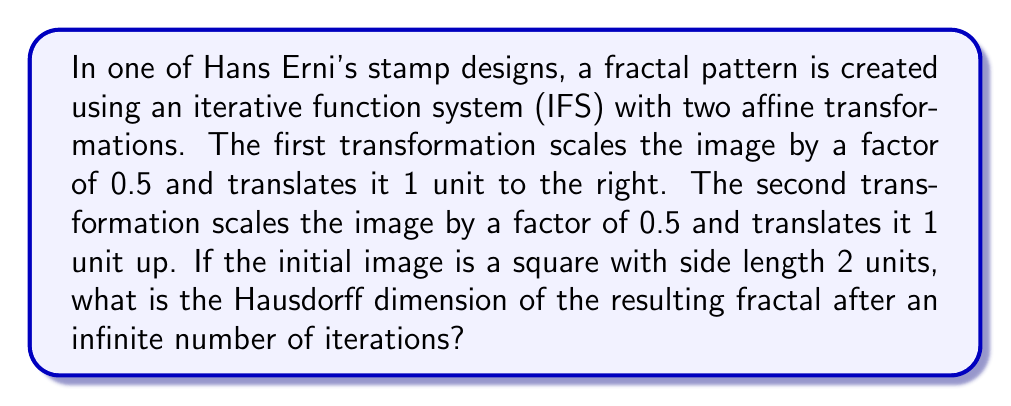Help me with this question. To solve this problem, we need to understand the concept of Hausdorff dimension and how it relates to iterative function systems.

1. First, let's define the two transformations:
   $$T_1(x,y) = (0.5x + 1, 0.5y)$$
   $$T_2(x,y) = (0.5x, 0.5y + 1)$$

2. The Hausdorff dimension for an IFS fractal can be calculated using the formula:
   $$\sum_{i=1}^n r_i^d = 1$$
   Where $n$ is the number of transformations, $r_i$ is the scaling factor for each transformation, and $d$ is the Hausdorff dimension.

3. In this case, we have two transformations ($n=2$), and both have the same scaling factor of 0.5. So our equation becomes:
   $$(0.5)^d + (0.5)^d = 1$$

4. Simplifying:
   $$2 \cdot (0.5)^d = 1$$

5. Taking the logarithm of both sides:
   $$\log_2(2 \cdot (0.5)^d) = \log_2(1)$$
   $$1 + d \cdot \log_2(0.5) = 0$$
   $$1 - d = 0$$

6. Solving for $d$:
   $$d = 1$$

Therefore, the Hausdorff dimension of this fractal is 1.

This result indicates that the fractal has a dimension between a point (0-dimensional) and a line (1-dimensional), but in this case, it coincides with the dimension of a line. This suggests that the fractal, while potentially having a complex structure, fills space in a way that is similar to a line in terms of its dimensional properties.
Answer: The Hausdorff dimension of the resulting fractal is 1. 